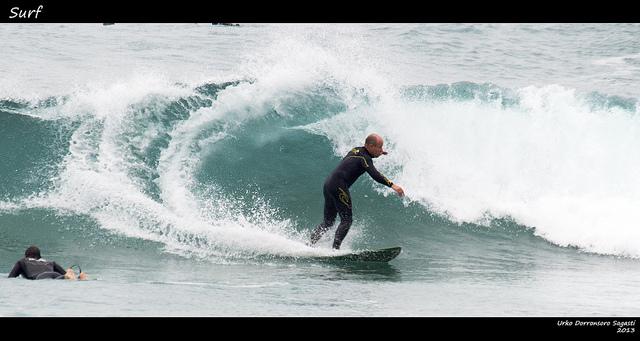Is this man snorkeling?
Write a very short answer. No. Is there a shark in the water?
Keep it brief. No. Would it be okay to drink that water?
Quick response, please. No. 